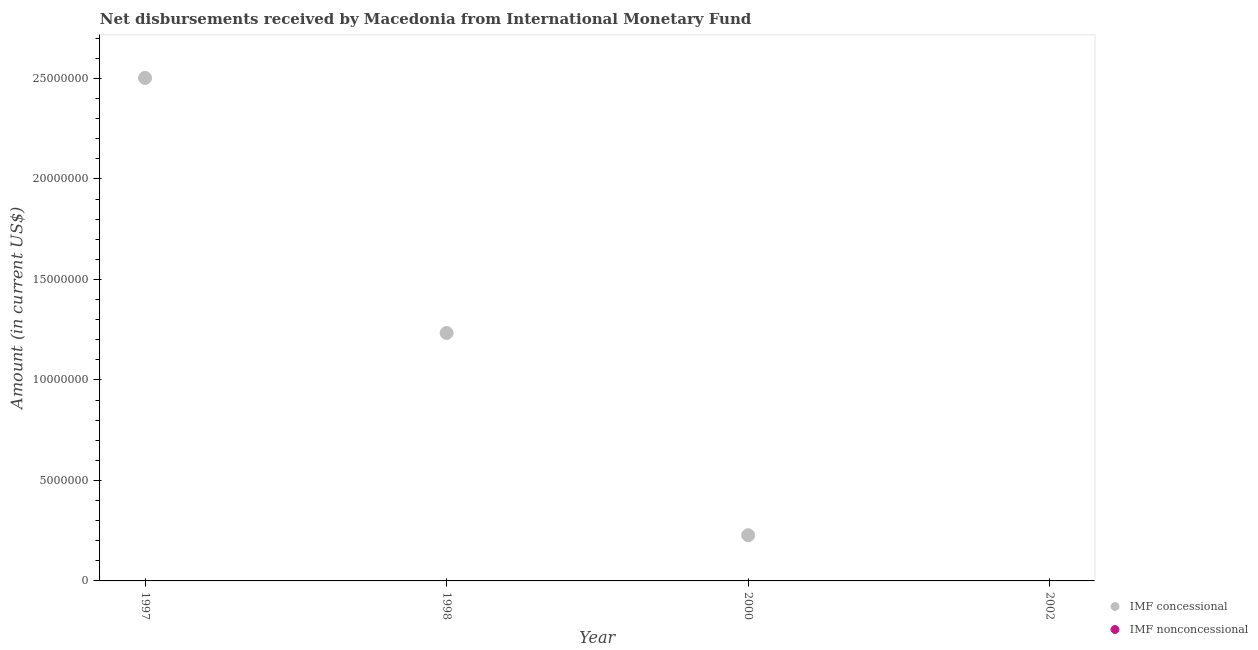How many different coloured dotlines are there?
Your answer should be very brief. 1. What is the net non concessional disbursements from imf in 2000?
Provide a short and direct response. 0. Across all years, what is the maximum net concessional disbursements from imf?
Offer a terse response. 2.50e+07. In which year was the net concessional disbursements from imf maximum?
Your answer should be compact. 1997. What is the total net non concessional disbursements from imf in the graph?
Keep it short and to the point. 0. What is the difference between the net concessional disbursements from imf in 1998 and that in 2000?
Provide a succinct answer. 1.01e+07. What is the difference between the net non concessional disbursements from imf in 1997 and the net concessional disbursements from imf in 1998?
Your response must be concise. -1.23e+07. What is the average net non concessional disbursements from imf per year?
Keep it short and to the point. 0. What is the ratio of the net concessional disbursements from imf in 1997 to that in 1998?
Keep it short and to the point. 2.03. Is the net concessional disbursements from imf in 1997 less than that in 1998?
Offer a terse response. No. What is the difference between the highest and the second highest net concessional disbursements from imf?
Make the answer very short. 1.27e+07. What is the difference between the highest and the lowest net concessional disbursements from imf?
Make the answer very short. 2.50e+07. In how many years, is the net concessional disbursements from imf greater than the average net concessional disbursements from imf taken over all years?
Your response must be concise. 2. Is the net concessional disbursements from imf strictly less than the net non concessional disbursements from imf over the years?
Give a very brief answer. No. How many dotlines are there?
Your response must be concise. 1. How many years are there in the graph?
Provide a short and direct response. 4. Are the values on the major ticks of Y-axis written in scientific E-notation?
Offer a terse response. No. Does the graph contain grids?
Make the answer very short. No. How many legend labels are there?
Ensure brevity in your answer.  2. What is the title of the graph?
Ensure brevity in your answer.  Net disbursements received by Macedonia from International Monetary Fund. What is the label or title of the X-axis?
Your answer should be compact. Year. What is the label or title of the Y-axis?
Make the answer very short. Amount (in current US$). What is the Amount (in current US$) in IMF concessional in 1997?
Provide a succinct answer. 2.50e+07. What is the Amount (in current US$) of IMF concessional in 1998?
Offer a very short reply. 1.23e+07. What is the Amount (in current US$) in IMF concessional in 2000?
Ensure brevity in your answer.  2.27e+06. What is the Amount (in current US$) in IMF concessional in 2002?
Your answer should be compact. 0. What is the Amount (in current US$) in IMF nonconcessional in 2002?
Give a very brief answer. 0. Across all years, what is the maximum Amount (in current US$) in IMF concessional?
Give a very brief answer. 2.50e+07. What is the total Amount (in current US$) in IMF concessional in the graph?
Provide a short and direct response. 3.96e+07. What is the difference between the Amount (in current US$) of IMF concessional in 1997 and that in 1998?
Your response must be concise. 1.27e+07. What is the difference between the Amount (in current US$) in IMF concessional in 1997 and that in 2000?
Your answer should be very brief. 2.28e+07. What is the difference between the Amount (in current US$) of IMF concessional in 1998 and that in 2000?
Keep it short and to the point. 1.01e+07. What is the average Amount (in current US$) of IMF concessional per year?
Provide a succinct answer. 9.91e+06. What is the average Amount (in current US$) in IMF nonconcessional per year?
Give a very brief answer. 0. What is the ratio of the Amount (in current US$) of IMF concessional in 1997 to that in 1998?
Make the answer very short. 2.03. What is the ratio of the Amount (in current US$) of IMF concessional in 1997 to that in 2000?
Ensure brevity in your answer.  11.01. What is the ratio of the Amount (in current US$) in IMF concessional in 1998 to that in 2000?
Give a very brief answer. 5.43. What is the difference between the highest and the second highest Amount (in current US$) in IMF concessional?
Make the answer very short. 1.27e+07. What is the difference between the highest and the lowest Amount (in current US$) of IMF concessional?
Your answer should be compact. 2.50e+07. 